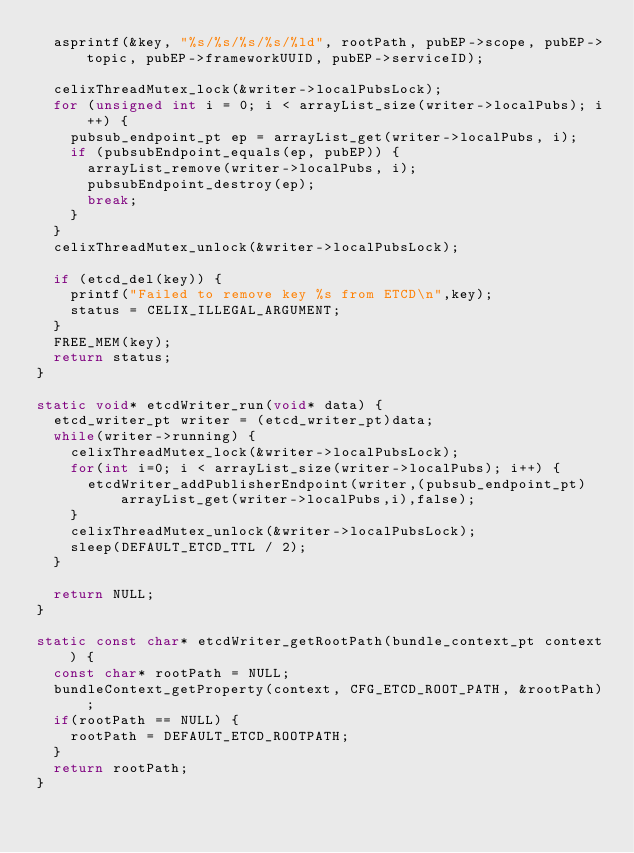Convert code to text. <code><loc_0><loc_0><loc_500><loc_500><_C_>	asprintf(&key, "%s/%s/%s/%s/%ld", rootPath, pubEP->scope, pubEP->topic, pubEP->frameworkUUID, pubEP->serviceID);

	celixThreadMutex_lock(&writer->localPubsLock);
	for (unsigned int i = 0; i < arrayList_size(writer->localPubs); i++) {
		pubsub_endpoint_pt ep = arrayList_get(writer->localPubs, i);
		if (pubsubEndpoint_equals(ep, pubEP)) {
			arrayList_remove(writer->localPubs, i);
			pubsubEndpoint_destroy(ep);
			break;
		}
	}
	celixThreadMutex_unlock(&writer->localPubsLock);

	if (etcd_del(key)) {
		printf("Failed to remove key %s from ETCD\n",key);
		status = CELIX_ILLEGAL_ARGUMENT;
	}
	FREE_MEM(key);
	return status;
}

static void* etcdWriter_run(void* data) {
	etcd_writer_pt writer = (etcd_writer_pt)data;
	while(writer->running) {
		celixThreadMutex_lock(&writer->localPubsLock);
		for(int i=0; i < arrayList_size(writer->localPubs); i++) {
			etcdWriter_addPublisherEndpoint(writer,(pubsub_endpoint_pt)arrayList_get(writer->localPubs,i),false);
		}
		celixThreadMutex_unlock(&writer->localPubsLock);
		sleep(DEFAULT_ETCD_TTL / 2);
	}

	return NULL;
}

static const char* etcdWriter_getRootPath(bundle_context_pt context) {
	const char* rootPath = NULL;
	bundleContext_getProperty(context, CFG_ETCD_ROOT_PATH, &rootPath);
	if(rootPath == NULL) {
		rootPath = DEFAULT_ETCD_ROOTPATH;
	}
	return rootPath;
}

</code> 